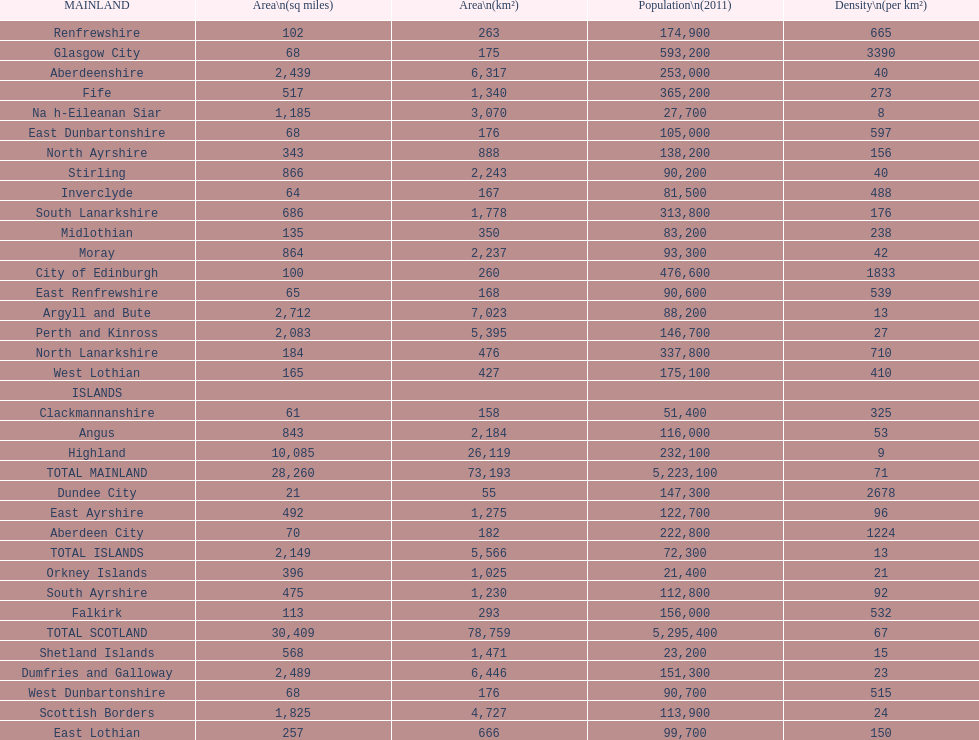If you were to arrange the locations from the smallest to largest area, which one would be first on the list? Dundee City. 